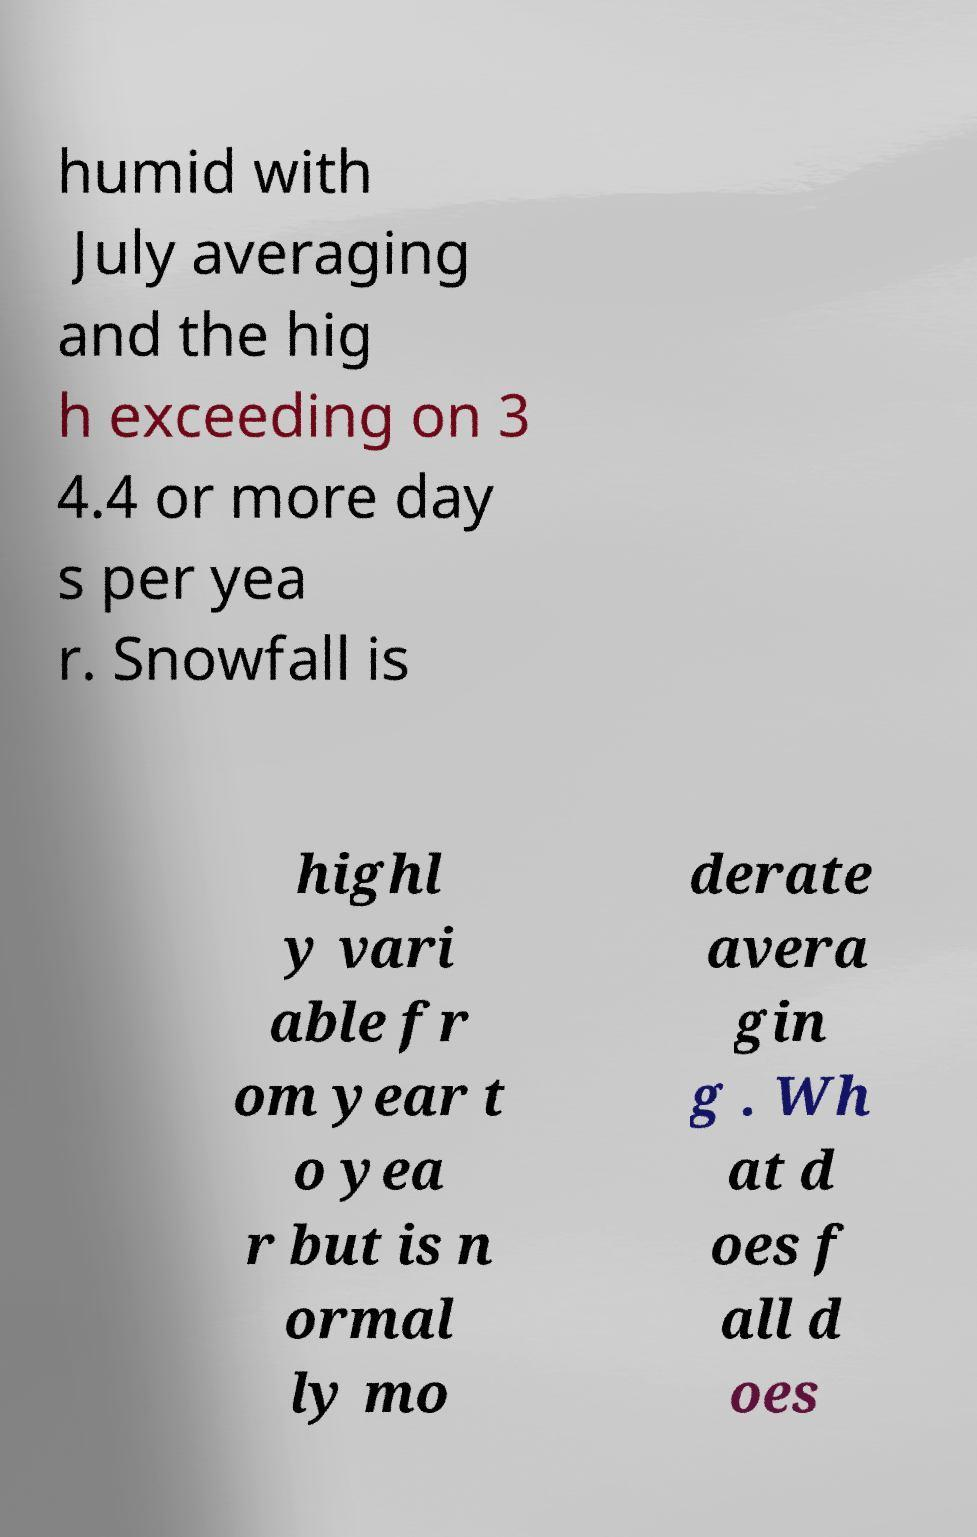Could you extract and type out the text from this image? humid with July averaging and the hig h exceeding on 3 4.4 or more day s per yea r. Snowfall is highl y vari able fr om year t o yea r but is n ormal ly mo derate avera gin g . Wh at d oes f all d oes 